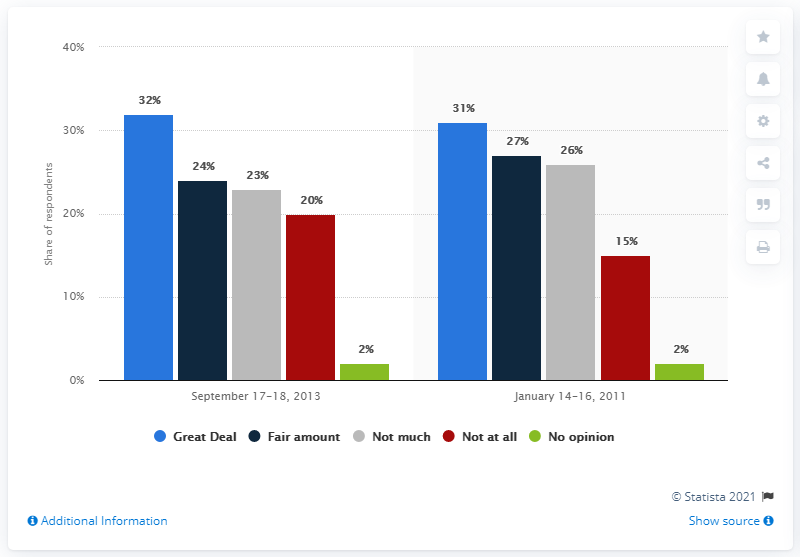Specify some key components in this picture. The percentage value of the green bar is 2. In 2013 and 2011, the color of a bar with the same value is green. 